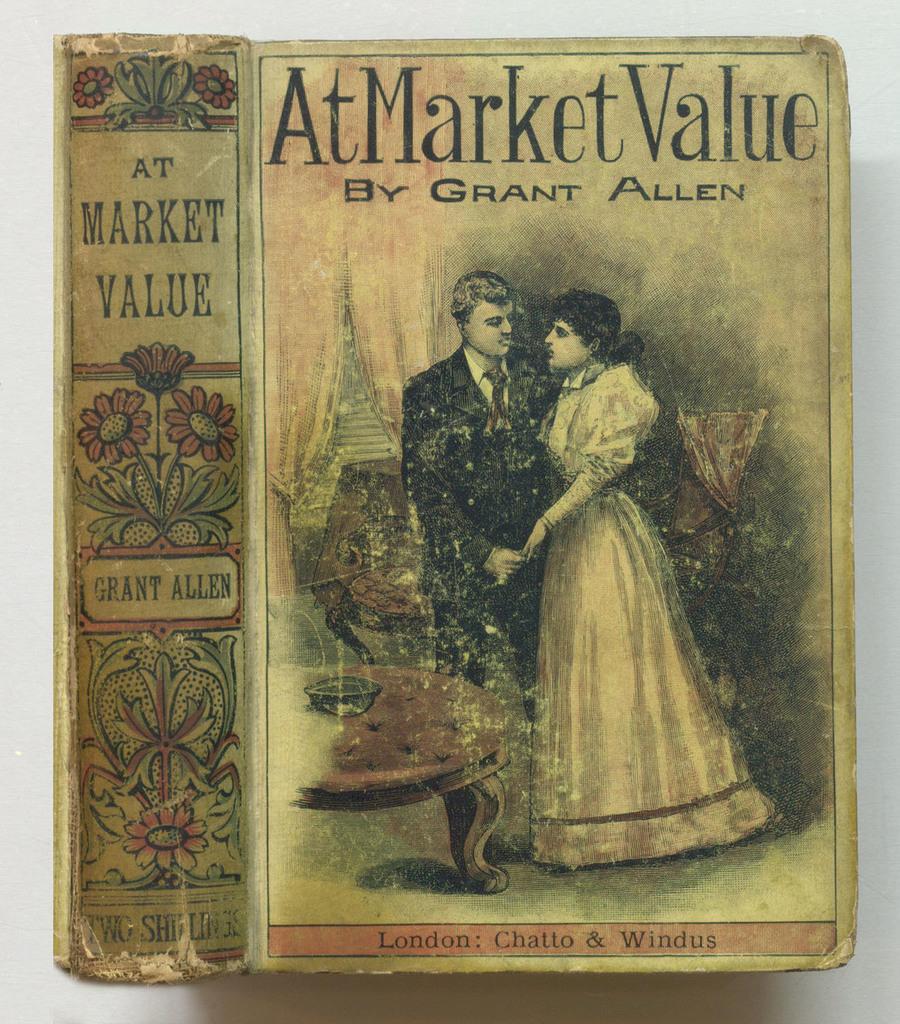What is the name of the author of the book?
Ensure brevity in your answer.  Grant allen. What is the book title?
Keep it short and to the point. At market value. 